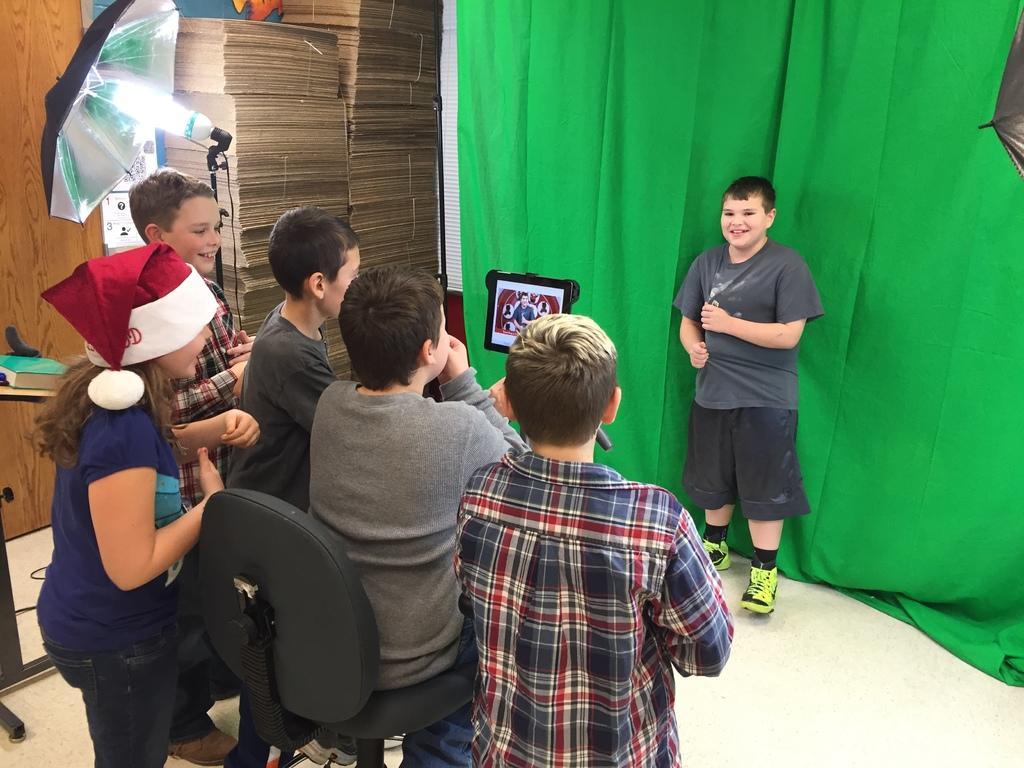Can you describe this image briefly? In this picture, we can see a few people, and a person is photographed, we can see the ground, and some objects on the ground like chair, pole, screen, umbrella, lights, and we can see the wall with some objects, and we can see green color cloth attached to the wall. 